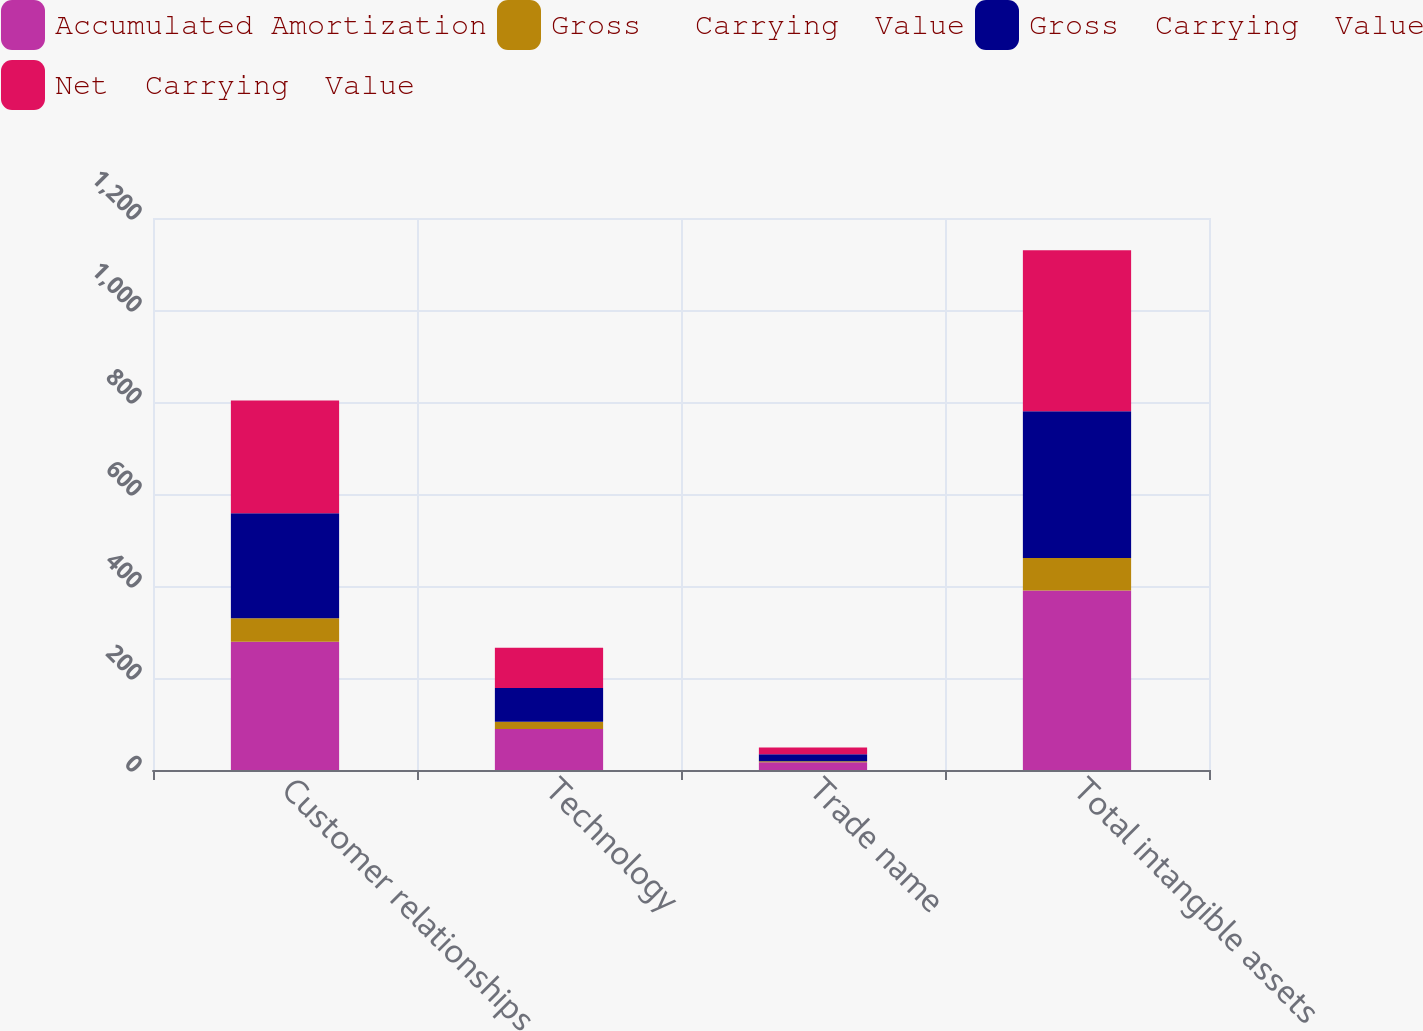Convert chart. <chart><loc_0><loc_0><loc_500><loc_500><stacked_bar_chart><ecel><fcel>Customer relationships<fcel>Technology<fcel>Trade name<fcel>Total intangible assets<nl><fcel>Accumulated Amortization<fcel>279<fcel>89<fcel>17<fcel>390<nl><fcel>Gross   Carrying  Value<fcel>51<fcel>16<fcel>2<fcel>71<nl><fcel>Gross  Carrying  Value<fcel>228<fcel>73<fcel>15<fcel>319<nl><fcel>Net  Carrying  Value<fcel>245<fcel>88<fcel>15<fcel>350<nl></chart> 